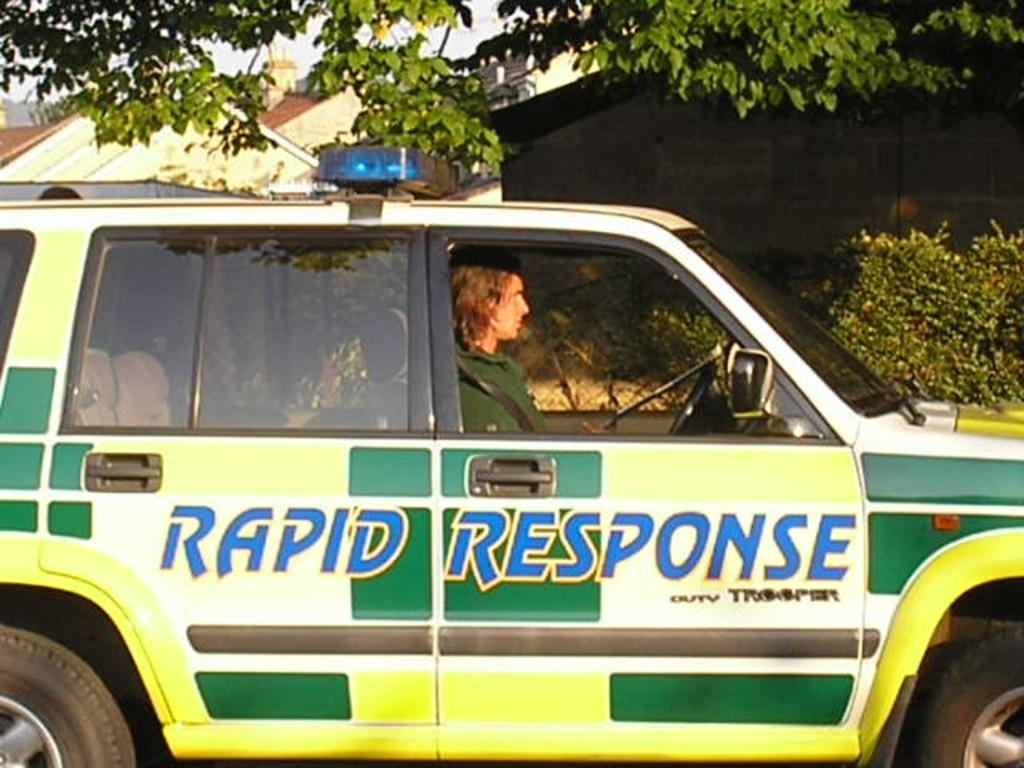What is the person in the image doing? There is a person sitting in a vehicle in the image. What can be seen on the vehicle? There is writing on the vehicle. What type of natural elements can be seen in the background of the image? There are plants, trees, and buildings in the background of the image. Can you describe the intensity of the rainstorm in the image? There is no rainstorm present in the image; it features a person sitting in a vehicle with writing on it, surrounded by plants, trees, and buildings in the background. 